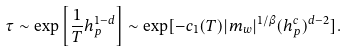<formula> <loc_0><loc_0><loc_500><loc_500>\tau \sim \exp \left [ \frac { 1 } { T } h _ { p } ^ { 1 - d } \right ] \sim \exp [ - c _ { 1 } ( T ) | m _ { w } | ^ { 1 / \beta } ( h _ { p } ^ { c } ) ^ { d - 2 } ] .</formula> 